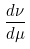<formula> <loc_0><loc_0><loc_500><loc_500>\frac { d \nu } { d \mu }</formula> 